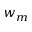Convert formula to latex. <formula><loc_0><loc_0><loc_500><loc_500>w _ { m }</formula> 